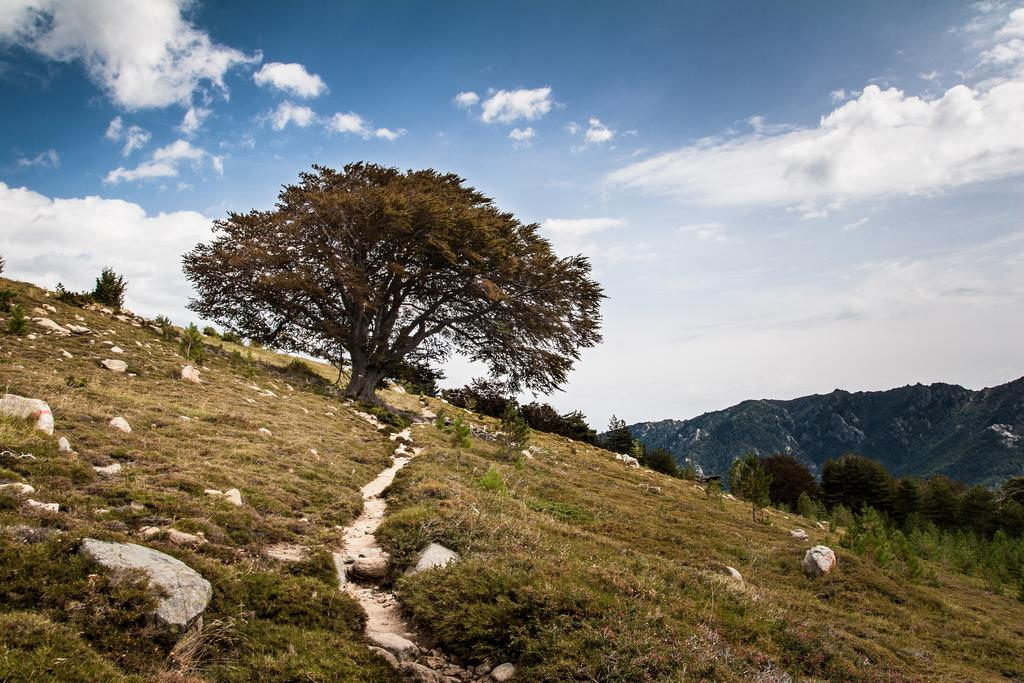What type of vegetation can be seen in the image? There are trees in the image. What can be seen in the distance in the image? There are hills visible in the background of the image. What is visible in the sky in the image? The sky is visible in the background of the image. What type of ground cover is present at the bottom of the image? There is grass at the bottom of the image. Can you tell me how many berries are growing on the trees in the image? There are no berries visible on the trees in the image; only trees are present. What type of respect is shown by the trees in the image? The trees in the image do not display any form of respect, as they are inanimate objects. 